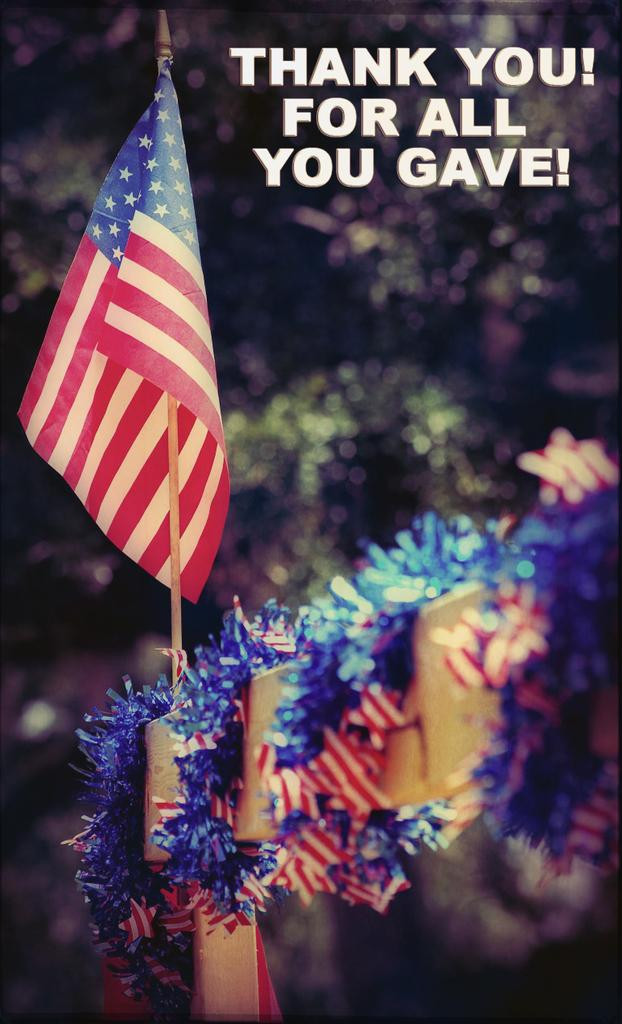What can be seen flying in the image? There is a flag in the image. What is wrapped around the fence in the image? There is a decorative item wrapped around a fence in the image. Is there any text or message on the decorative item? Yes, there is something written on the decorative item. What type of bone can be seen in the image? There is no bone present in the image. Are there any police officers visible in the image? There is no mention of police officers in the provided facts, so we cannot determine if they are present in the image. 